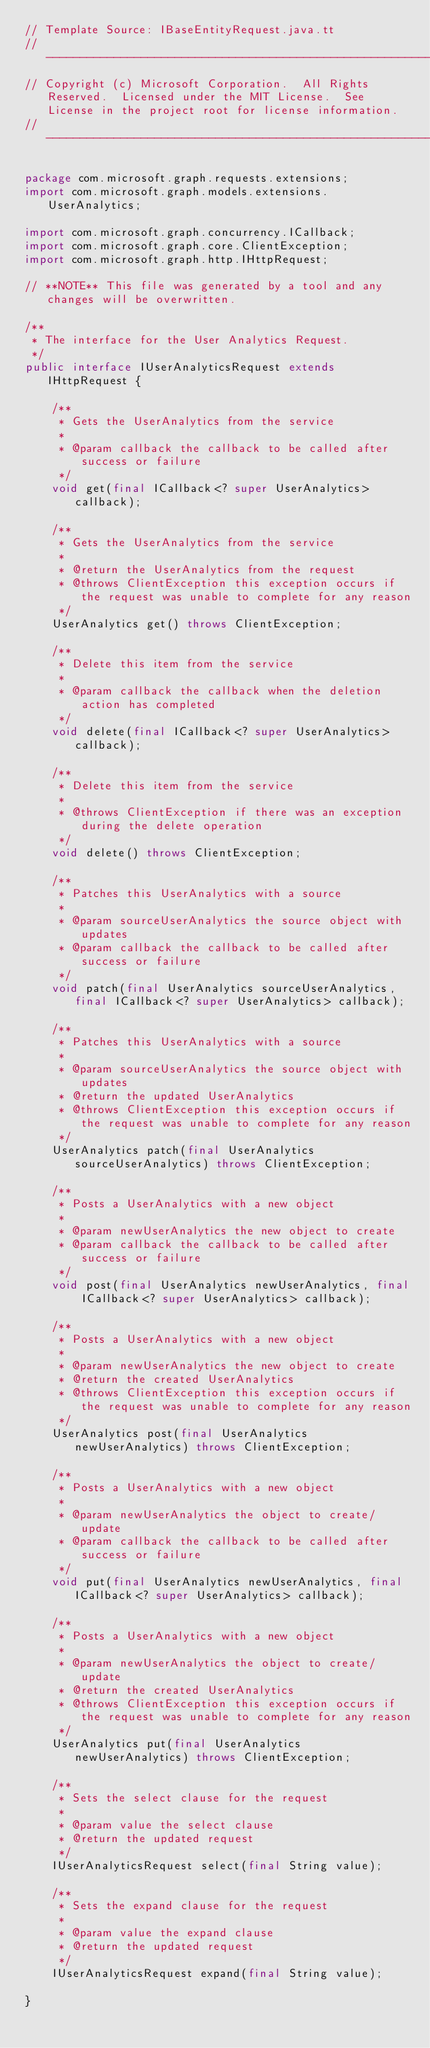Convert code to text. <code><loc_0><loc_0><loc_500><loc_500><_Java_>// Template Source: IBaseEntityRequest.java.tt
// ------------------------------------------------------------------------------
// Copyright (c) Microsoft Corporation.  All Rights Reserved.  Licensed under the MIT License.  See License in the project root for license information.
// ------------------------------------------------------------------------------

package com.microsoft.graph.requests.extensions;
import com.microsoft.graph.models.extensions.UserAnalytics;

import com.microsoft.graph.concurrency.ICallback;
import com.microsoft.graph.core.ClientException;
import com.microsoft.graph.http.IHttpRequest;

// **NOTE** This file was generated by a tool and any changes will be overwritten.

/**
 * The interface for the User Analytics Request.
 */
public interface IUserAnalyticsRequest extends IHttpRequest {

    /**
     * Gets the UserAnalytics from the service
     *
     * @param callback the callback to be called after success or failure
     */
    void get(final ICallback<? super UserAnalytics> callback);

    /**
     * Gets the UserAnalytics from the service
     *
     * @return the UserAnalytics from the request
     * @throws ClientException this exception occurs if the request was unable to complete for any reason
     */
    UserAnalytics get() throws ClientException;

    /**
     * Delete this item from the service
     *
     * @param callback the callback when the deletion action has completed
     */
    void delete(final ICallback<? super UserAnalytics> callback);

    /**
     * Delete this item from the service
     *
     * @throws ClientException if there was an exception during the delete operation
     */
    void delete() throws ClientException;

    /**
     * Patches this UserAnalytics with a source
     *
     * @param sourceUserAnalytics the source object with updates
     * @param callback the callback to be called after success or failure
     */
    void patch(final UserAnalytics sourceUserAnalytics, final ICallback<? super UserAnalytics> callback);

    /**
     * Patches this UserAnalytics with a source
     *
     * @param sourceUserAnalytics the source object with updates
     * @return the updated UserAnalytics
     * @throws ClientException this exception occurs if the request was unable to complete for any reason
     */
    UserAnalytics patch(final UserAnalytics sourceUserAnalytics) throws ClientException;

    /**
     * Posts a UserAnalytics with a new object
     *
     * @param newUserAnalytics the new object to create
     * @param callback the callback to be called after success or failure
     */
    void post(final UserAnalytics newUserAnalytics, final ICallback<? super UserAnalytics> callback);

    /**
     * Posts a UserAnalytics with a new object
     *
     * @param newUserAnalytics the new object to create
     * @return the created UserAnalytics
     * @throws ClientException this exception occurs if the request was unable to complete for any reason
     */
    UserAnalytics post(final UserAnalytics newUserAnalytics) throws ClientException;

    /**
     * Posts a UserAnalytics with a new object
     *
     * @param newUserAnalytics the object to create/update
     * @param callback the callback to be called after success or failure
     */
    void put(final UserAnalytics newUserAnalytics, final ICallback<? super UserAnalytics> callback);

    /**
     * Posts a UserAnalytics with a new object
     *
     * @param newUserAnalytics the object to create/update
     * @return the created UserAnalytics
     * @throws ClientException this exception occurs if the request was unable to complete for any reason
     */
    UserAnalytics put(final UserAnalytics newUserAnalytics) throws ClientException;

    /**
     * Sets the select clause for the request
     *
     * @param value the select clause
     * @return the updated request
     */
    IUserAnalyticsRequest select(final String value);

    /**
     * Sets the expand clause for the request
     *
     * @param value the expand clause
     * @return the updated request
     */
    IUserAnalyticsRequest expand(final String value);

}

</code> 